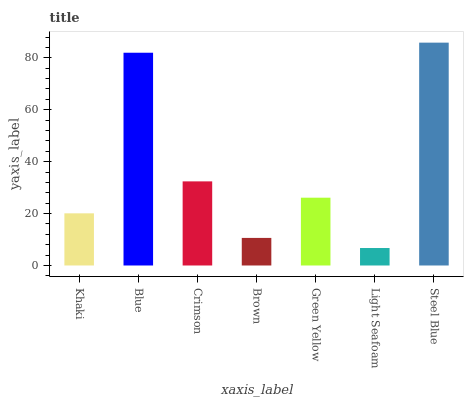Is Light Seafoam the minimum?
Answer yes or no. Yes. Is Steel Blue the maximum?
Answer yes or no. Yes. Is Blue the minimum?
Answer yes or no. No. Is Blue the maximum?
Answer yes or no. No. Is Blue greater than Khaki?
Answer yes or no. Yes. Is Khaki less than Blue?
Answer yes or no. Yes. Is Khaki greater than Blue?
Answer yes or no. No. Is Blue less than Khaki?
Answer yes or no. No. Is Green Yellow the high median?
Answer yes or no. Yes. Is Green Yellow the low median?
Answer yes or no. Yes. Is Steel Blue the high median?
Answer yes or no. No. Is Blue the low median?
Answer yes or no. No. 